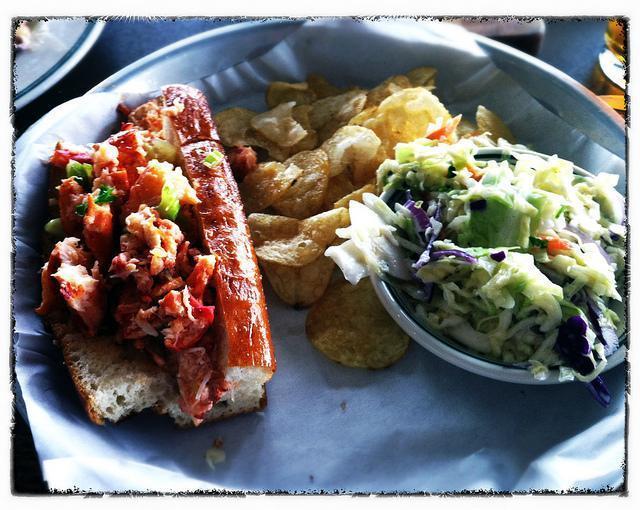Is the caption "The sandwich is at the left side of the bowl." a true representation of the image?
Answer yes or no. Yes. 